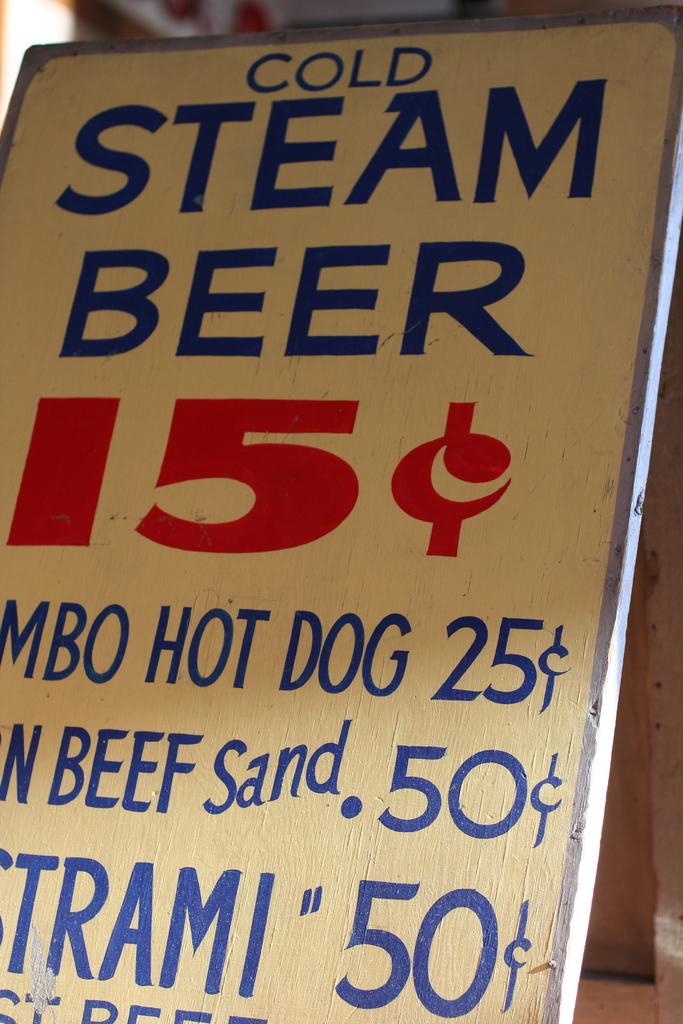How much does the beer cost?
Ensure brevity in your answer.  15 cents. 